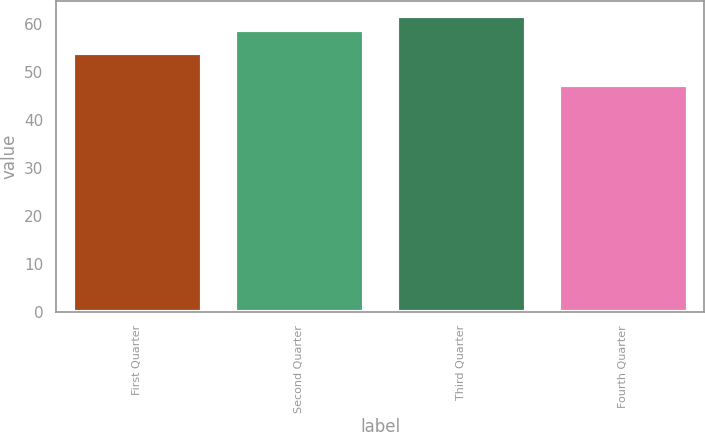<chart> <loc_0><loc_0><loc_500><loc_500><bar_chart><fcel>First Quarter<fcel>Second Quarter<fcel>Third Quarter<fcel>Fourth Quarter<nl><fcel>54.08<fcel>58.91<fcel>61.75<fcel>47.37<nl></chart> 